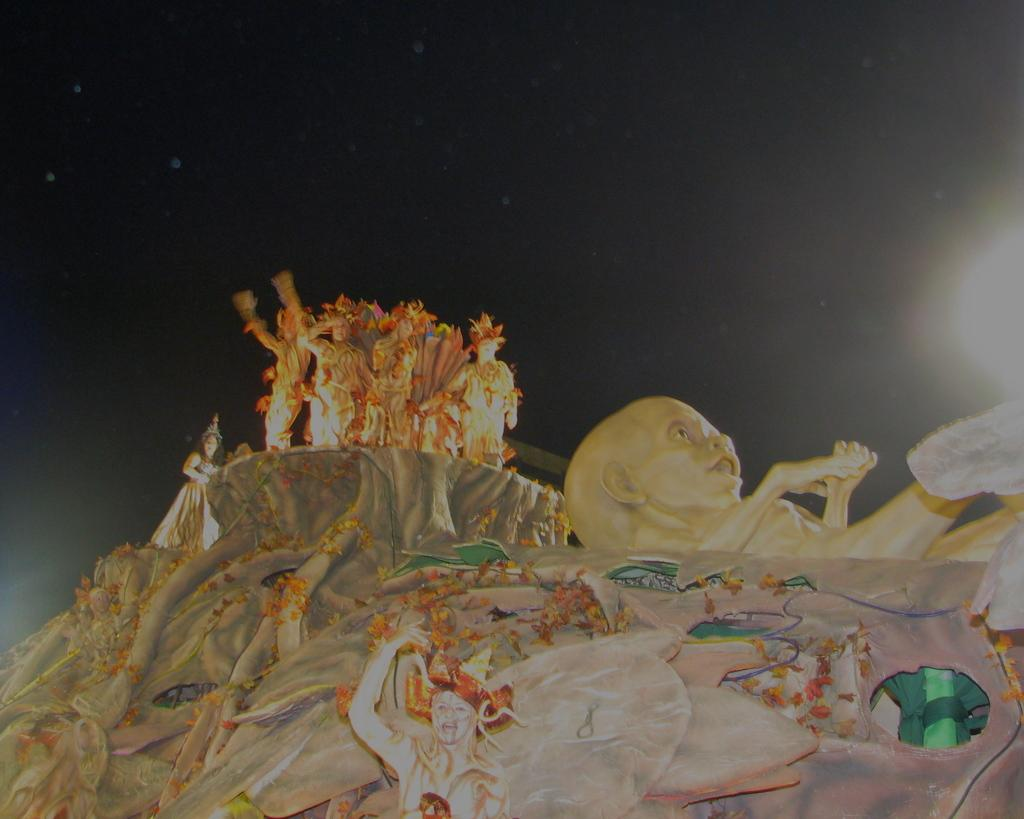What is the main subject of the image? The main subject of the image is a sculpture. What are the people in the image doing? The people are standing at the top of the sculpture. What are the people wearing? The people are wearing costumes. What is the color of the background in the image? The background of the image is dark. What type of curtain is hanging from the sculpture? There is no curtain present in the image. The image features a sculpture with people standing at the top, wearing costumes, and a dark background. 